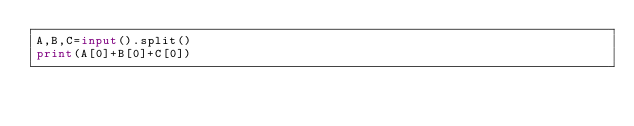Convert code to text. <code><loc_0><loc_0><loc_500><loc_500><_Python_>A,B,C=input().split()
print(A[0]+B[0]+C[0])</code> 